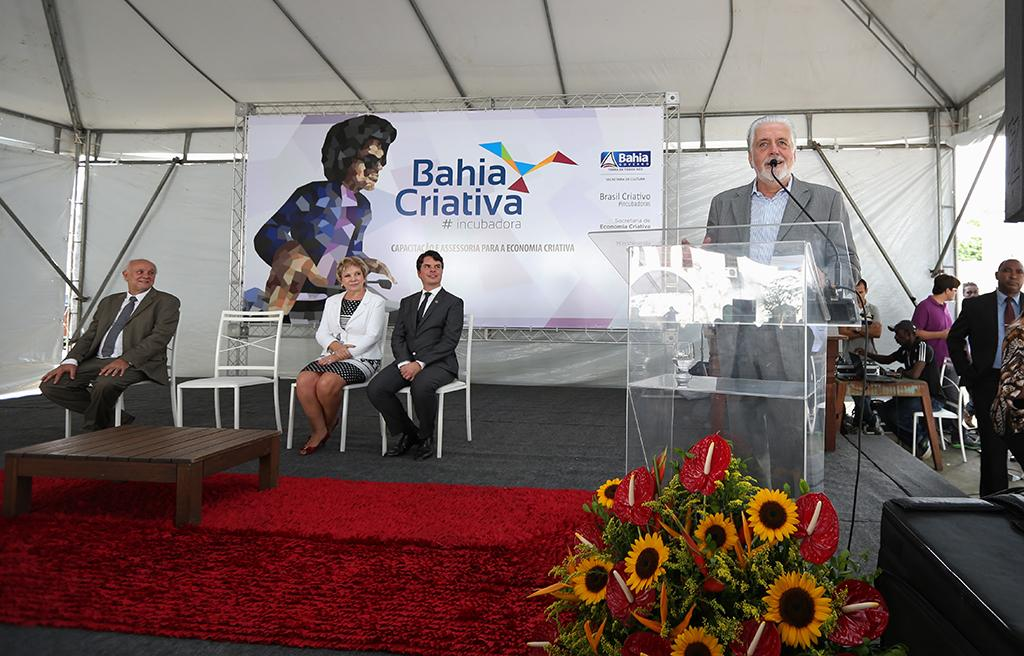How many people are in the image? There are people in the image, but the exact number is not specified. What are some of the people doing in the image? Some of the people are sitting, and some are standing. What type of furniture is present in the image? There are chairs in the image. What else can be seen in the image besides people and furniture? There are plants and a table in the image. Can you see a sofa in the image? No, there is no sofa present in the image. Is there a river visible in the image? No, there is no river present in the image. 